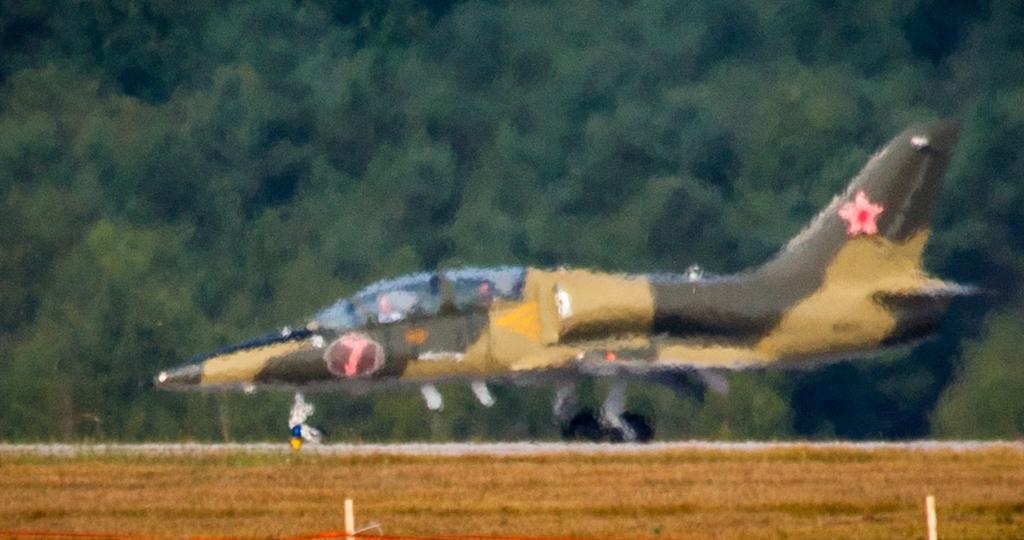Please provide a concise description of this image. In this picture there is an aircraft in the center of the image and there are trees in the background area of the image. 